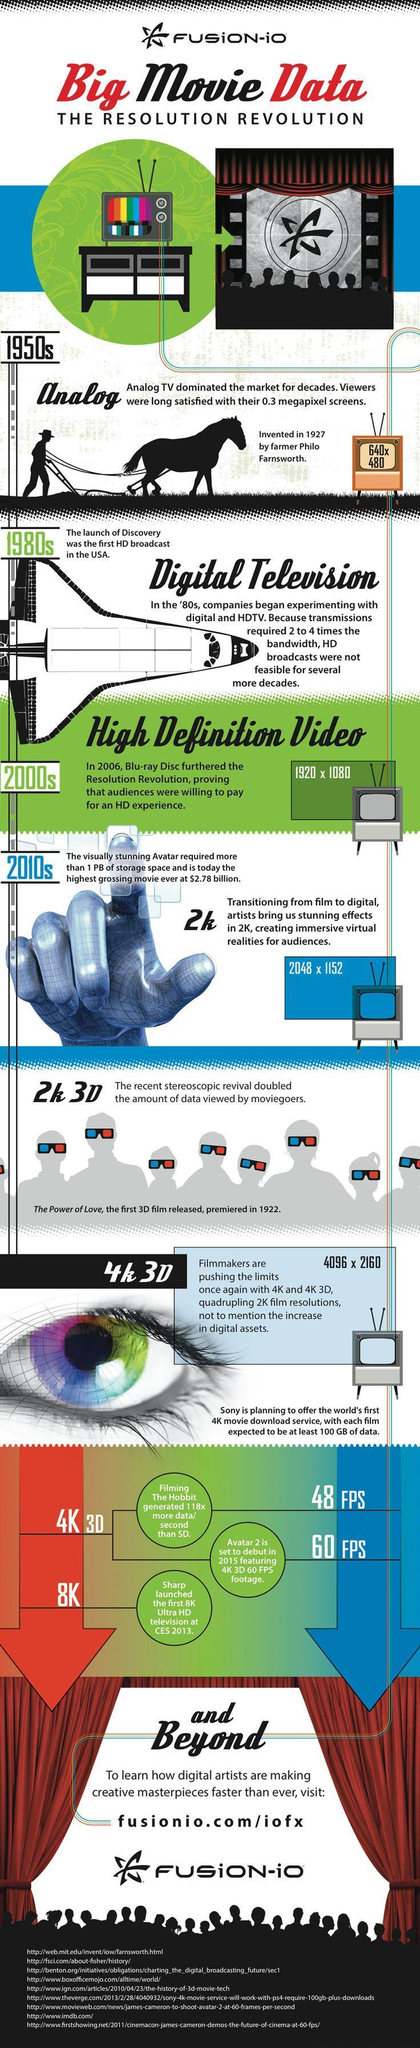How many sources are listed at the bottom?
Answer the question with a short phrase. 9 Which type of video has a resolution of 2048 x 1152? 2k What was the resolution of High definition videos? 1920 x 1080 What was the resolution of analog TV? 640 x 480 Which is the latest in digital resolution? 8K 